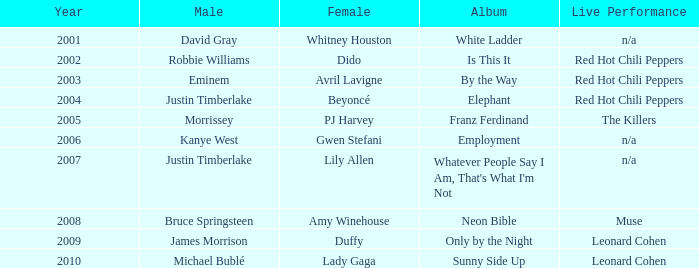Who is the male counterpart for amy winehouse? Bruce Springsteen. 